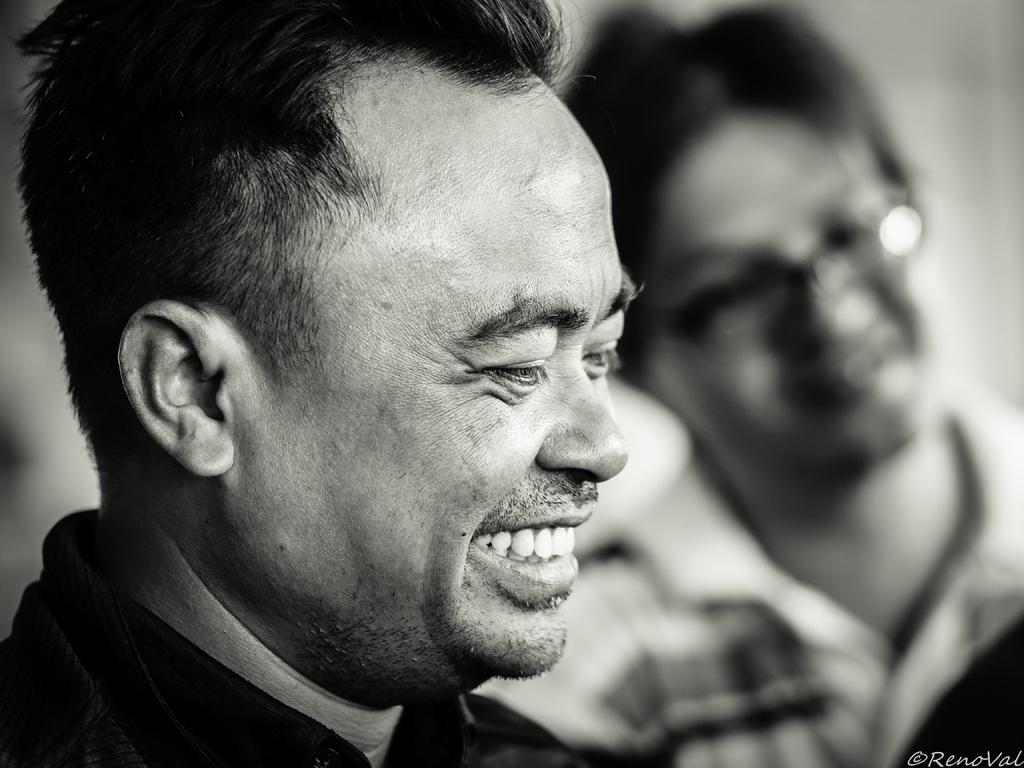What is the color scheme of the image? The image is black and white. What is the expression of the person in the image? The person in the image is smiling. How would you describe the background of the image? The background is blurred. Can you tell me if there is more than one person in the image? Yes, there is another person in the image. Is there any text or logo visible in the image? Yes, there is a watermark in the right bottom corner of the image. Can you see any dinosaurs in the image? No, there are no dinosaurs present in the image. What type of authority is depicted in the image? There is no authority figure depicted in the image. 